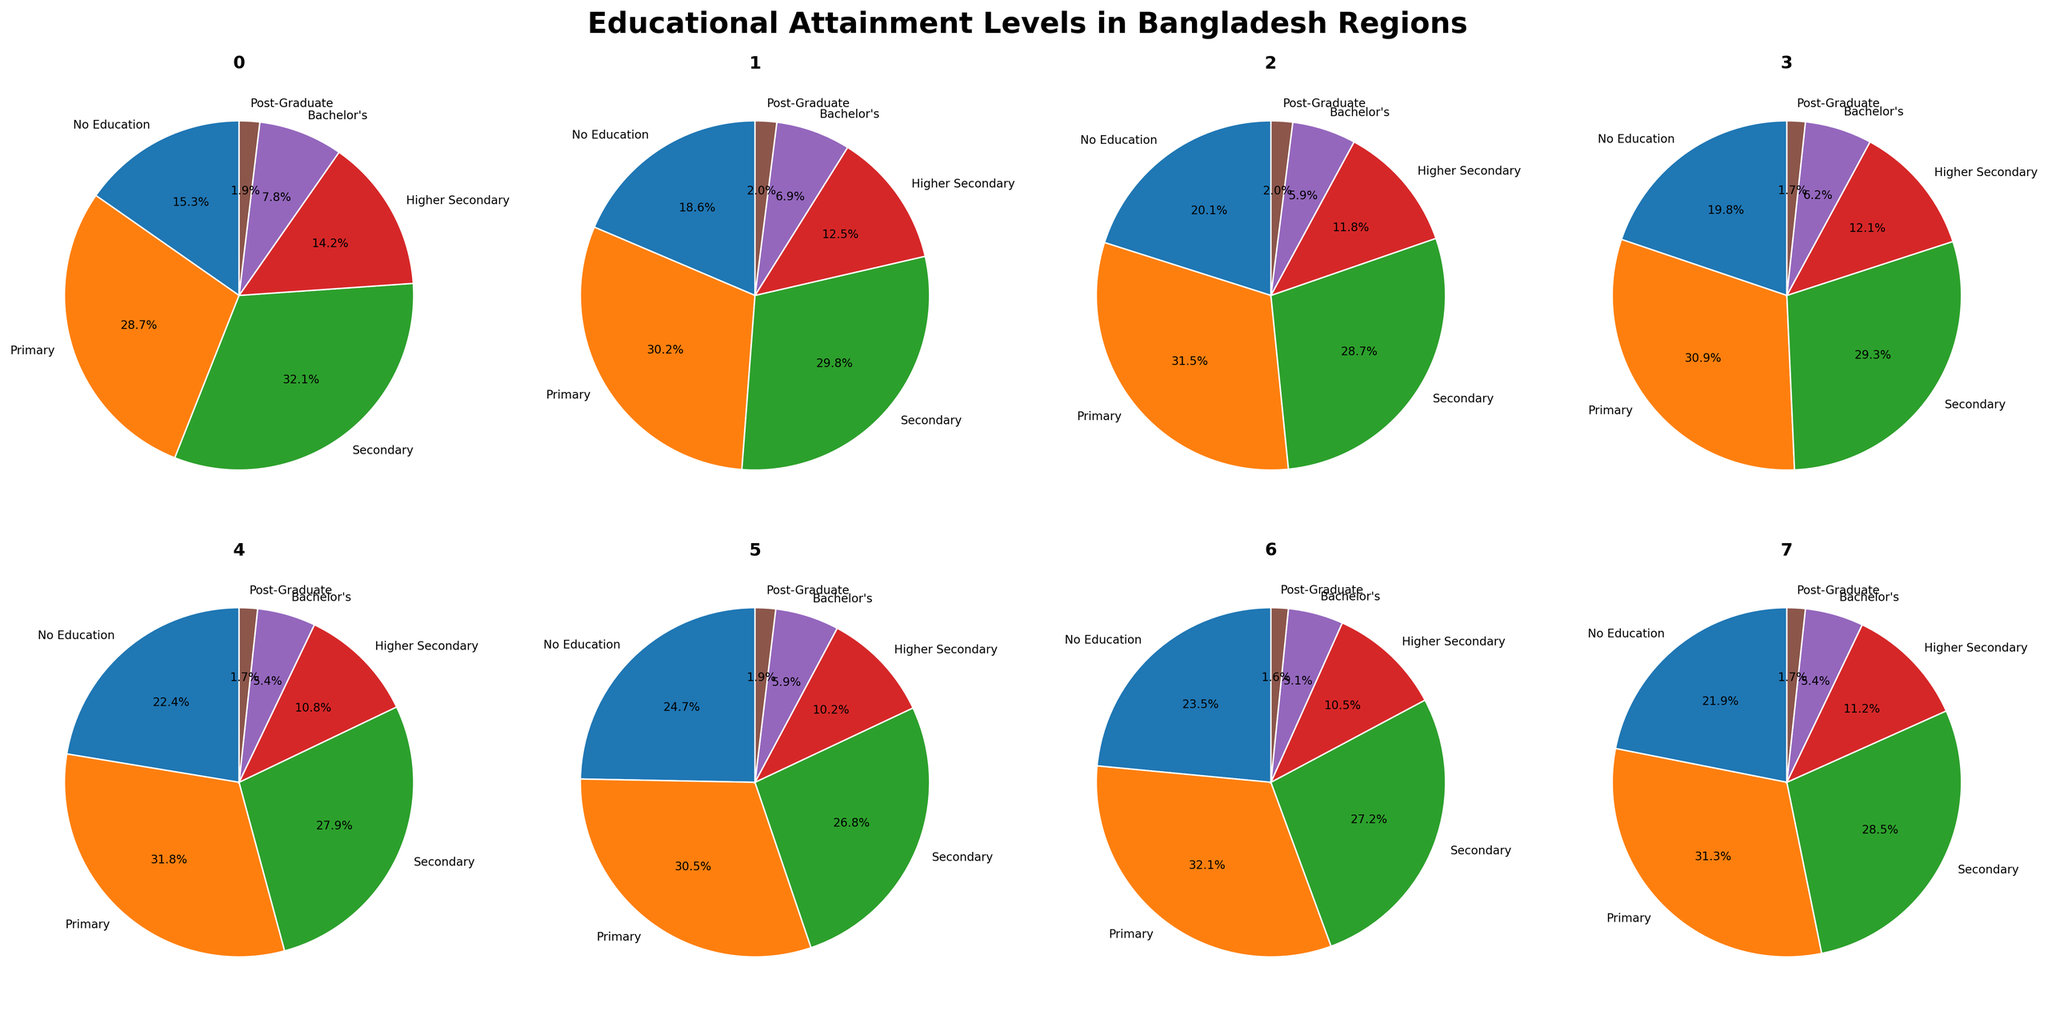What's the region with the highest percentage of people having no education? By examining the pie charts in each subplot, observe the section labeled "No Education." Compare the percentages to find the highest value.
Answer: Sylhet Which region has the highest proportion of individuals with primary education? Check the pie chart sections labeled "Primary" for all regions. Identify the region with the largest percentage.
Answer: Rajshahi What is the total percentage of people with secondary education in Dhaka and Chittagong combined? Locate the "Secondary" percentage for Dhaka (32.1%) and Chittagong (29.8%). Add these percentages: 32.1 + 29.8.
Answer: 61.9% Which regions show a higher percentage of post-graduates compared to Khulna? Khulna's post-graduate percentage is 1.7%. Identify regions with values higher than this by checking the "Post-Graduate" sections in the pie charts.
Answer: Dhaka and Chittagong In which region do individuals with Bachelor's degrees constitute exactly 5.4%? Examine each pie chart section labeled "Bachelor's" to identify the region with 5.4%.
Answer: Barisal and Mymensingh Compare the proportion of individuals having no education between Barisal and Rangpur. Which has a higher percentage? Look at the "No Education" sections for Barisal (22.4%) and Rangpur (23.5%) and compare.
Answer: Rangpur What is the combined percentage of people with higher secondary and post-graduate levels in Sylhet? Locate Sylhet's "Higher Secondary" (10.2%) and "Post-Graduate" (1.9%) percentages and add them: 10.2 + 1.9.
Answer: 12.1% Which region has the smallest proportion of people educated at the higher secondary level? Check the "Higher Secondary" sections for all regions and identify the smallest value.
Answer: Sylhet Which region has the highest percentage of individuals with a Bachelor's degree? Identify the region with the largest section labeled "Bachelor's."
Answer: Dhaka How much higher is the percentage of people with secondary education in Dhaka compared to Barisal? Find "Secondary" percentages for Dhaka (32.1%) and Barisal (27.9%). Subtract Barisal's percentage from Dhaka's: 32.1 - 27.9.
Answer: 4.2% 